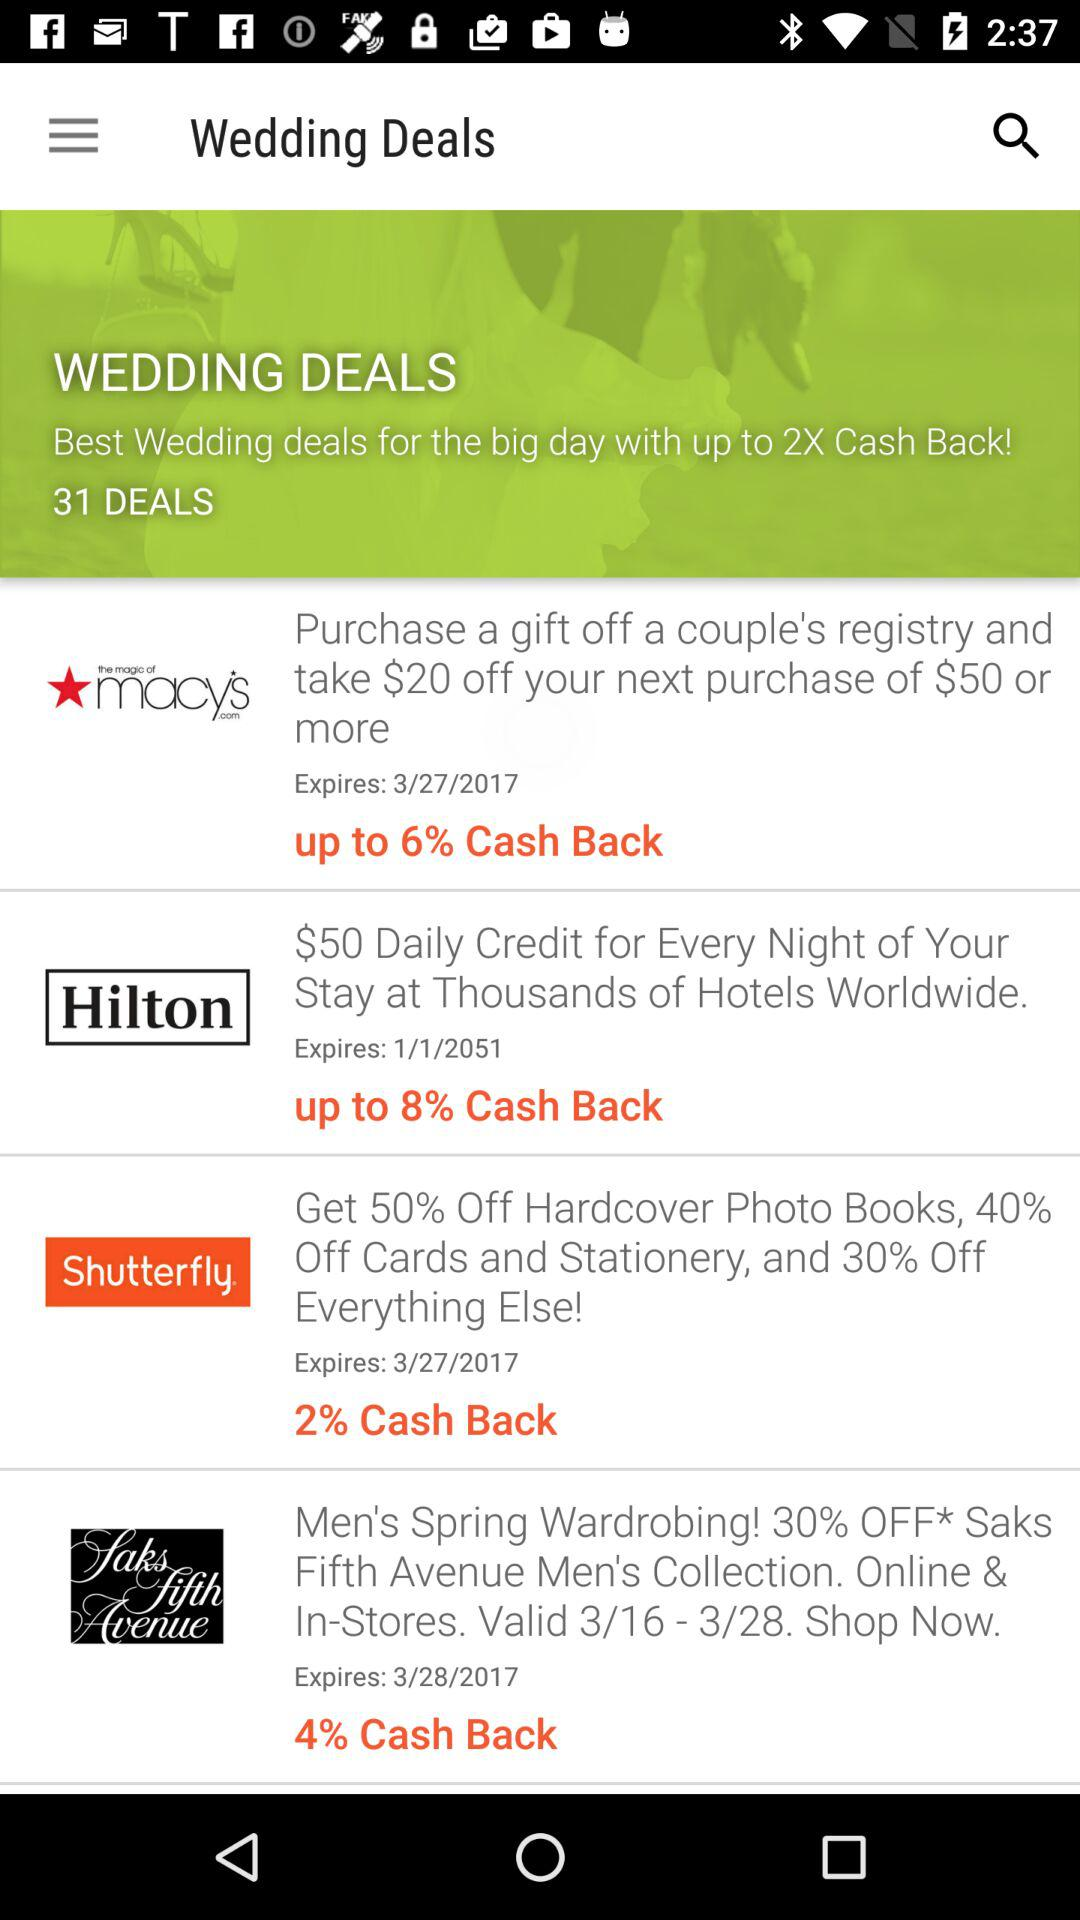How many of the deals have an expiration date of 3/27/2017?
Answer the question using a single word or phrase. 2 